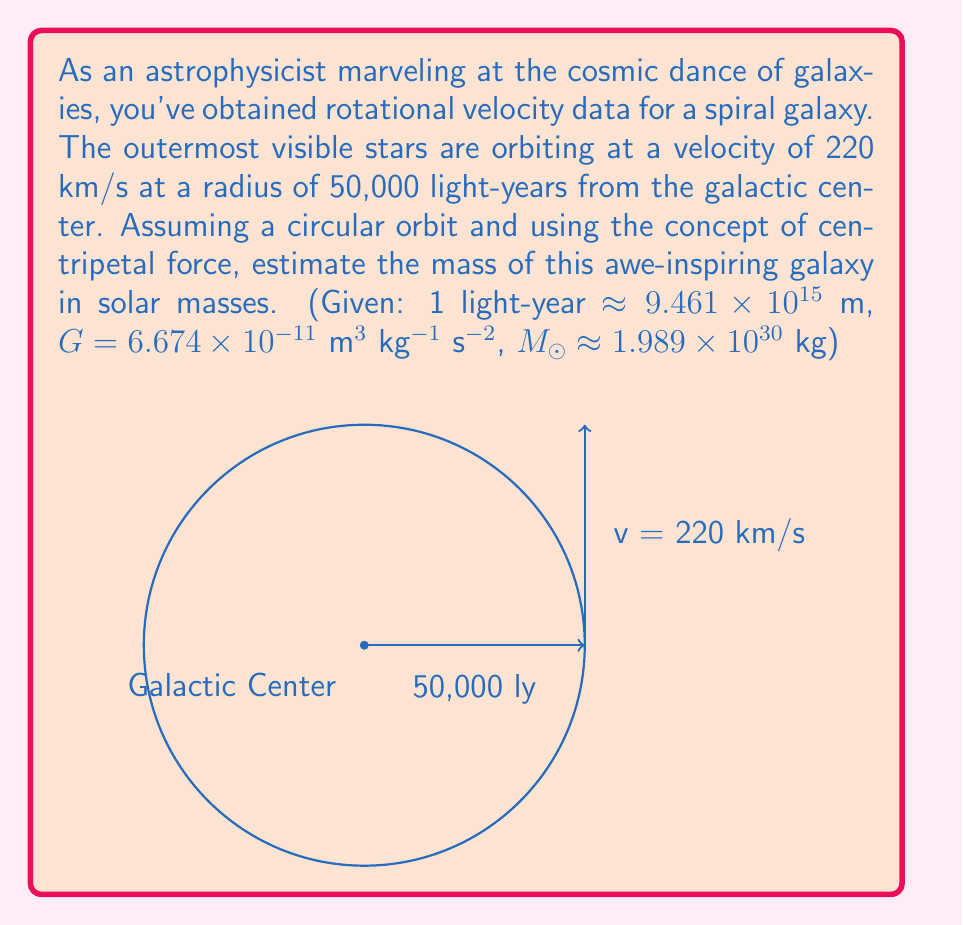Can you answer this question? Let's approach this step-by-step:

1) For a circular orbit, the centripetal force is provided by gravity. We can equate these forces:

   $$\frac{GMm}{r^2} = \frac{mv^2}{r}$$

   Where $G$ is the gravitational constant, $M$ is the mass of the galaxy, $m$ is the mass of the orbiting star, $r$ is the radius, and $v$ is the orbital velocity.

2) The $m$ cancels out on both sides, giving us:

   $$\frac{GM}{r^2} = \frac{v^2}{r}$$

3) Solving for $M$:

   $$M = \frac{rv^2}{G}$$

4) Now, let's convert our units:
   - $r = 50,000 \text{ light-years} = 50,000 \times 9.461 \times 10^{15} \text{ m} = 4.7305 \times 10^{20} \text{ m}$
   - $v = 220 \text{ km/s} = 2.2 \times 10^5 \text{ m/s}$

5) Substituting these values and $G = 6.674 \times 10^{-11} \text{ m}^3 \text{ kg}^{-1} \text{ s}^{-2}$:

   $$M = \frac{(4.7305 \times 10^{20})(2.2 \times 10^5)^2}{6.674 \times 10^{-11}}$$

6) Calculating:

   $$M = 3.39 \times 10^{41} \text{ kg}$$

7) Converting to solar masses:

   $$M = \frac{3.39 \times 10^{41}}{1.989 \times 10^{30}} = 1.70 \times 10^{11} M_☉$$
Answer: $1.70 \times 10^{11} M_☉$ 